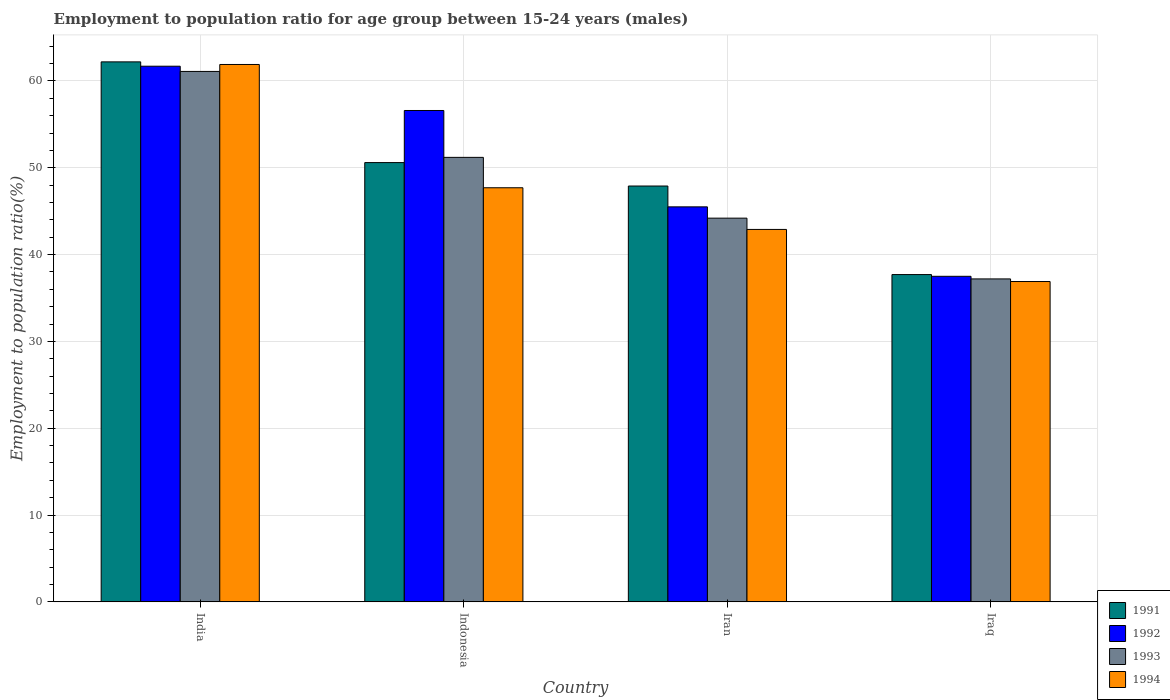How many groups of bars are there?
Ensure brevity in your answer.  4. Are the number of bars per tick equal to the number of legend labels?
Give a very brief answer. Yes. Are the number of bars on each tick of the X-axis equal?
Give a very brief answer. Yes. How many bars are there on the 3rd tick from the right?
Offer a terse response. 4. What is the label of the 3rd group of bars from the left?
Your answer should be very brief. Iran. What is the employment to population ratio in 1991 in Indonesia?
Ensure brevity in your answer.  50.6. Across all countries, what is the maximum employment to population ratio in 1991?
Provide a short and direct response. 62.2. Across all countries, what is the minimum employment to population ratio in 1991?
Provide a short and direct response. 37.7. In which country was the employment to population ratio in 1992 minimum?
Make the answer very short. Iraq. What is the total employment to population ratio in 1992 in the graph?
Make the answer very short. 201.3. What is the difference between the employment to population ratio in 1992 in India and the employment to population ratio in 1994 in Iraq?
Give a very brief answer. 24.8. What is the average employment to population ratio in 1992 per country?
Provide a succinct answer. 50.32. What is the difference between the employment to population ratio of/in 1992 and employment to population ratio of/in 1994 in India?
Your answer should be compact. -0.2. In how many countries, is the employment to population ratio in 1993 greater than 4 %?
Keep it short and to the point. 4. What is the ratio of the employment to population ratio in 1991 in Indonesia to that in Iraq?
Provide a succinct answer. 1.34. Is the employment to population ratio in 1992 in India less than that in Iran?
Give a very brief answer. No. What is the difference between the highest and the second highest employment to population ratio in 1991?
Your response must be concise. -11.6. In how many countries, is the employment to population ratio in 1993 greater than the average employment to population ratio in 1993 taken over all countries?
Ensure brevity in your answer.  2. Is the sum of the employment to population ratio in 1993 in Iran and Iraq greater than the maximum employment to population ratio in 1992 across all countries?
Your response must be concise. Yes. Is it the case that in every country, the sum of the employment to population ratio in 1992 and employment to population ratio in 1991 is greater than the sum of employment to population ratio in 1993 and employment to population ratio in 1994?
Your response must be concise. No. What does the 3rd bar from the left in Indonesia represents?
Your answer should be compact. 1993. What does the 4th bar from the right in Indonesia represents?
Make the answer very short. 1991. How many bars are there?
Make the answer very short. 16. Are all the bars in the graph horizontal?
Offer a terse response. No. How many countries are there in the graph?
Make the answer very short. 4. Are the values on the major ticks of Y-axis written in scientific E-notation?
Your answer should be compact. No. Does the graph contain any zero values?
Give a very brief answer. No. What is the title of the graph?
Provide a short and direct response. Employment to population ratio for age group between 15-24 years (males). What is the label or title of the X-axis?
Your answer should be very brief. Country. What is the Employment to population ratio(%) of 1991 in India?
Keep it short and to the point. 62.2. What is the Employment to population ratio(%) in 1992 in India?
Your answer should be very brief. 61.7. What is the Employment to population ratio(%) in 1993 in India?
Keep it short and to the point. 61.1. What is the Employment to population ratio(%) in 1994 in India?
Give a very brief answer. 61.9. What is the Employment to population ratio(%) in 1991 in Indonesia?
Offer a very short reply. 50.6. What is the Employment to population ratio(%) in 1992 in Indonesia?
Provide a short and direct response. 56.6. What is the Employment to population ratio(%) in 1993 in Indonesia?
Keep it short and to the point. 51.2. What is the Employment to population ratio(%) in 1994 in Indonesia?
Offer a terse response. 47.7. What is the Employment to population ratio(%) in 1991 in Iran?
Your response must be concise. 47.9. What is the Employment to population ratio(%) in 1992 in Iran?
Make the answer very short. 45.5. What is the Employment to population ratio(%) in 1993 in Iran?
Provide a short and direct response. 44.2. What is the Employment to population ratio(%) in 1994 in Iran?
Offer a very short reply. 42.9. What is the Employment to population ratio(%) of 1991 in Iraq?
Keep it short and to the point. 37.7. What is the Employment to population ratio(%) of 1992 in Iraq?
Your response must be concise. 37.5. What is the Employment to population ratio(%) in 1993 in Iraq?
Give a very brief answer. 37.2. What is the Employment to population ratio(%) of 1994 in Iraq?
Your response must be concise. 36.9. Across all countries, what is the maximum Employment to population ratio(%) of 1991?
Provide a succinct answer. 62.2. Across all countries, what is the maximum Employment to population ratio(%) of 1992?
Provide a short and direct response. 61.7. Across all countries, what is the maximum Employment to population ratio(%) of 1993?
Give a very brief answer. 61.1. Across all countries, what is the maximum Employment to population ratio(%) of 1994?
Give a very brief answer. 61.9. Across all countries, what is the minimum Employment to population ratio(%) of 1991?
Offer a very short reply. 37.7. Across all countries, what is the minimum Employment to population ratio(%) of 1992?
Ensure brevity in your answer.  37.5. Across all countries, what is the minimum Employment to population ratio(%) of 1993?
Your answer should be very brief. 37.2. Across all countries, what is the minimum Employment to population ratio(%) of 1994?
Provide a short and direct response. 36.9. What is the total Employment to population ratio(%) in 1991 in the graph?
Offer a very short reply. 198.4. What is the total Employment to population ratio(%) of 1992 in the graph?
Your answer should be very brief. 201.3. What is the total Employment to population ratio(%) of 1993 in the graph?
Ensure brevity in your answer.  193.7. What is the total Employment to population ratio(%) of 1994 in the graph?
Provide a short and direct response. 189.4. What is the difference between the Employment to population ratio(%) in 1991 in India and that in Indonesia?
Your answer should be very brief. 11.6. What is the difference between the Employment to population ratio(%) in 1992 in India and that in Indonesia?
Provide a succinct answer. 5.1. What is the difference between the Employment to population ratio(%) in 1993 in India and that in Indonesia?
Keep it short and to the point. 9.9. What is the difference between the Employment to population ratio(%) in 1994 in India and that in Indonesia?
Offer a terse response. 14.2. What is the difference between the Employment to population ratio(%) in 1991 in India and that in Iran?
Provide a succinct answer. 14.3. What is the difference between the Employment to population ratio(%) of 1992 in India and that in Iran?
Make the answer very short. 16.2. What is the difference between the Employment to population ratio(%) in 1994 in India and that in Iran?
Give a very brief answer. 19. What is the difference between the Employment to population ratio(%) in 1991 in India and that in Iraq?
Provide a succinct answer. 24.5. What is the difference between the Employment to population ratio(%) in 1992 in India and that in Iraq?
Offer a very short reply. 24.2. What is the difference between the Employment to population ratio(%) of 1993 in India and that in Iraq?
Your response must be concise. 23.9. What is the difference between the Employment to population ratio(%) of 1992 in Indonesia and that in Iran?
Keep it short and to the point. 11.1. What is the difference between the Employment to population ratio(%) of 1993 in Indonesia and that in Iran?
Your response must be concise. 7. What is the difference between the Employment to population ratio(%) of 1991 in Indonesia and that in Iraq?
Offer a very short reply. 12.9. What is the difference between the Employment to population ratio(%) of 1994 in Indonesia and that in Iraq?
Keep it short and to the point. 10.8. What is the difference between the Employment to population ratio(%) in 1991 in Iran and that in Iraq?
Provide a succinct answer. 10.2. What is the difference between the Employment to population ratio(%) in 1994 in Iran and that in Iraq?
Offer a very short reply. 6. What is the difference between the Employment to population ratio(%) of 1991 in India and the Employment to population ratio(%) of 1992 in Indonesia?
Make the answer very short. 5.6. What is the difference between the Employment to population ratio(%) in 1991 in India and the Employment to population ratio(%) in 1994 in Indonesia?
Give a very brief answer. 14.5. What is the difference between the Employment to population ratio(%) of 1992 in India and the Employment to population ratio(%) of 1993 in Indonesia?
Provide a short and direct response. 10.5. What is the difference between the Employment to population ratio(%) of 1993 in India and the Employment to population ratio(%) of 1994 in Indonesia?
Give a very brief answer. 13.4. What is the difference between the Employment to population ratio(%) in 1991 in India and the Employment to population ratio(%) in 1992 in Iran?
Offer a terse response. 16.7. What is the difference between the Employment to population ratio(%) of 1991 in India and the Employment to population ratio(%) of 1993 in Iran?
Your answer should be compact. 18. What is the difference between the Employment to population ratio(%) in 1991 in India and the Employment to population ratio(%) in 1994 in Iran?
Keep it short and to the point. 19.3. What is the difference between the Employment to population ratio(%) in 1992 in India and the Employment to population ratio(%) in 1994 in Iran?
Keep it short and to the point. 18.8. What is the difference between the Employment to population ratio(%) in 1993 in India and the Employment to population ratio(%) in 1994 in Iran?
Provide a succinct answer. 18.2. What is the difference between the Employment to population ratio(%) of 1991 in India and the Employment to population ratio(%) of 1992 in Iraq?
Give a very brief answer. 24.7. What is the difference between the Employment to population ratio(%) of 1991 in India and the Employment to population ratio(%) of 1993 in Iraq?
Keep it short and to the point. 25. What is the difference between the Employment to population ratio(%) in 1991 in India and the Employment to population ratio(%) in 1994 in Iraq?
Your response must be concise. 25.3. What is the difference between the Employment to population ratio(%) of 1992 in India and the Employment to population ratio(%) of 1994 in Iraq?
Your answer should be compact. 24.8. What is the difference between the Employment to population ratio(%) of 1993 in India and the Employment to population ratio(%) of 1994 in Iraq?
Your response must be concise. 24.2. What is the difference between the Employment to population ratio(%) in 1991 in Indonesia and the Employment to population ratio(%) in 1992 in Iraq?
Provide a succinct answer. 13.1. What is the difference between the Employment to population ratio(%) in 1991 in Iran and the Employment to population ratio(%) in 1994 in Iraq?
Give a very brief answer. 11. What is the difference between the Employment to population ratio(%) of 1992 in Iran and the Employment to population ratio(%) of 1993 in Iraq?
Give a very brief answer. 8.3. What is the average Employment to population ratio(%) in 1991 per country?
Offer a terse response. 49.6. What is the average Employment to population ratio(%) in 1992 per country?
Ensure brevity in your answer.  50.33. What is the average Employment to population ratio(%) in 1993 per country?
Your response must be concise. 48.42. What is the average Employment to population ratio(%) of 1994 per country?
Your answer should be very brief. 47.35. What is the difference between the Employment to population ratio(%) of 1991 and Employment to population ratio(%) of 1992 in India?
Offer a very short reply. 0.5. What is the difference between the Employment to population ratio(%) of 1991 and Employment to population ratio(%) of 1994 in India?
Offer a terse response. 0.3. What is the difference between the Employment to population ratio(%) of 1993 and Employment to population ratio(%) of 1994 in India?
Provide a succinct answer. -0.8. What is the difference between the Employment to population ratio(%) of 1991 and Employment to population ratio(%) of 1992 in Indonesia?
Keep it short and to the point. -6. What is the difference between the Employment to population ratio(%) in 1991 and Employment to population ratio(%) in 1993 in Indonesia?
Your response must be concise. -0.6. What is the difference between the Employment to population ratio(%) of 1991 and Employment to population ratio(%) of 1994 in Indonesia?
Keep it short and to the point. 2.9. What is the difference between the Employment to population ratio(%) in 1991 and Employment to population ratio(%) in 1992 in Iran?
Your answer should be compact. 2.4. What is the difference between the Employment to population ratio(%) of 1991 and Employment to population ratio(%) of 1993 in Iran?
Keep it short and to the point. 3.7. What is the difference between the Employment to population ratio(%) in 1991 and Employment to population ratio(%) in 1994 in Iran?
Make the answer very short. 5. What is the difference between the Employment to population ratio(%) of 1992 and Employment to population ratio(%) of 1993 in Iran?
Keep it short and to the point. 1.3. What is the difference between the Employment to population ratio(%) of 1991 and Employment to population ratio(%) of 1993 in Iraq?
Provide a succinct answer. 0.5. What is the difference between the Employment to population ratio(%) in 1991 and Employment to population ratio(%) in 1994 in Iraq?
Make the answer very short. 0.8. What is the difference between the Employment to population ratio(%) of 1992 and Employment to population ratio(%) of 1993 in Iraq?
Your answer should be compact. 0.3. What is the difference between the Employment to population ratio(%) of 1993 and Employment to population ratio(%) of 1994 in Iraq?
Offer a terse response. 0.3. What is the ratio of the Employment to population ratio(%) in 1991 in India to that in Indonesia?
Provide a succinct answer. 1.23. What is the ratio of the Employment to population ratio(%) of 1992 in India to that in Indonesia?
Offer a very short reply. 1.09. What is the ratio of the Employment to population ratio(%) of 1993 in India to that in Indonesia?
Give a very brief answer. 1.19. What is the ratio of the Employment to population ratio(%) in 1994 in India to that in Indonesia?
Give a very brief answer. 1.3. What is the ratio of the Employment to population ratio(%) in 1991 in India to that in Iran?
Your response must be concise. 1.3. What is the ratio of the Employment to population ratio(%) in 1992 in India to that in Iran?
Keep it short and to the point. 1.36. What is the ratio of the Employment to population ratio(%) of 1993 in India to that in Iran?
Give a very brief answer. 1.38. What is the ratio of the Employment to population ratio(%) in 1994 in India to that in Iran?
Provide a short and direct response. 1.44. What is the ratio of the Employment to population ratio(%) of 1991 in India to that in Iraq?
Ensure brevity in your answer.  1.65. What is the ratio of the Employment to population ratio(%) of 1992 in India to that in Iraq?
Your answer should be compact. 1.65. What is the ratio of the Employment to population ratio(%) in 1993 in India to that in Iraq?
Ensure brevity in your answer.  1.64. What is the ratio of the Employment to population ratio(%) in 1994 in India to that in Iraq?
Make the answer very short. 1.68. What is the ratio of the Employment to population ratio(%) in 1991 in Indonesia to that in Iran?
Give a very brief answer. 1.06. What is the ratio of the Employment to population ratio(%) in 1992 in Indonesia to that in Iran?
Give a very brief answer. 1.24. What is the ratio of the Employment to population ratio(%) of 1993 in Indonesia to that in Iran?
Offer a terse response. 1.16. What is the ratio of the Employment to population ratio(%) in 1994 in Indonesia to that in Iran?
Offer a very short reply. 1.11. What is the ratio of the Employment to population ratio(%) of 1991 in Indonesia to that in Iraq?
Your answer should be compact. 1.34. What is the ratio of the Employment to population ratio(%) of 1992 in Indonesia to that in Iraq?
Provide a succinct answer. 1.51. What is the ratio of the Employment to population ratio(%) of 1993 in Indonesia to that in Iraq?
Give a very brief answer. 1.38. What is the ratio of the Employment to population ratio(%) in 1994 in Indonesia to that in Iraq?
Provide a succinct answer. 1.29. What is the ratio of the Employment to population ratio(%) of 1991 in Iran to that in Iraq?
Provide a short and direct response. 1.27. What is the ratio of the Employment to population ratio(%) in 1992 in Iran to that in Iraq?
Ensure brevity in your answer.  1.21. What is the ratio of the Employment to population ratio(%) of 1993 in Iran to that in Iraq?
Your response must be concise. 1.19. What is the ratio of the Employment to population ratio(%) in 1994 in Iran to that in Iraq?
Provide a short and direct response. 1.16. What is the difference between the highest and the lowest Employment to population ratio(%) of 1991?
Your answer should be very brief. 24.5. What is the difference between the highest and the lowest Employment to population ratio(%) in 1992?
Give a very brief answer. 24.2. What is the difference between the highest and the lowest Employment to population ratio(%) in 1993?
Your answer should be very brief. 23.9. 